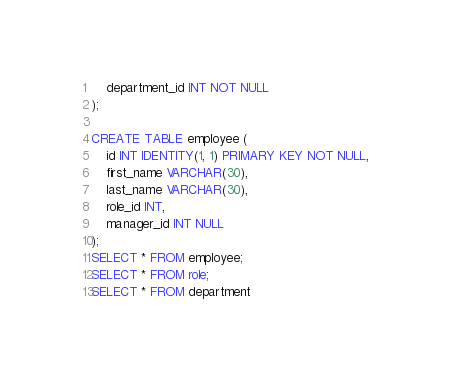<code> <loc_0><loc_0><loc_500><loc_500><_SQL_>    department_id INT NOT NULL
);

CREATE TABLE employee (
    id INT IDENTITY(1, 1) PRIMARY KEY NOT NULL,
    first_name VARCHAR(30),
    last_name VARCHAR(30),
    role_id INT,
    manager_id INT NULL
);
SELECT * FROM employee;
SELECT * FROM role;
SELECT * FROM department
</code> 